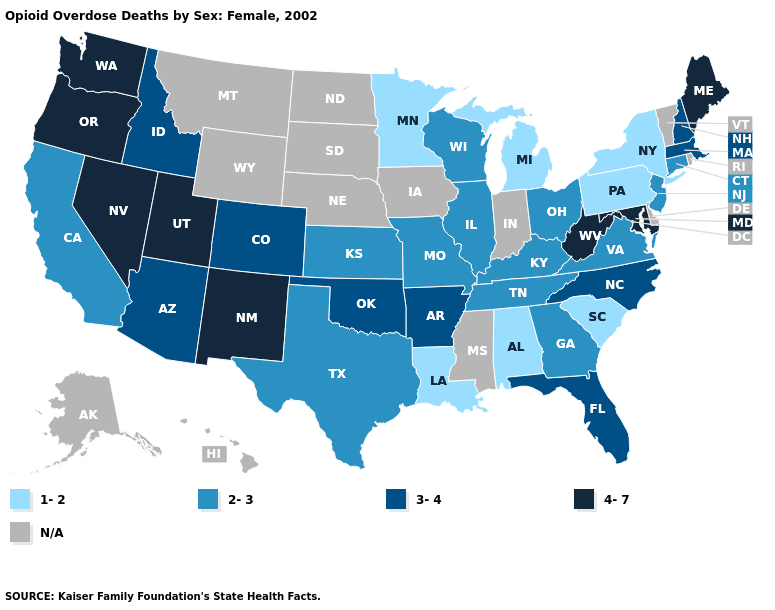What is the highest value in the USA?
Keep it brief. 4-7. How many symbols are there in the legend?
Short answer required. 5. Which states have the lowest value in the Northeast?
Short answer required. New York, Pennsylvania. Does Oregon have the highest value in the USA?
Keep it brief. Yes. What is the value of Tennessee?
Give a very brief answer. 2-3. Among the states that border North Carolina , does South Carolina have the lowest value?
Quick response, please. Yes. What is the value of Nevada?
Concise answer only. 4-7. Name the states that have a value in the range 2-3?
Short answer required. California, Connecticut, Georgia, Illinois, Kansas, Kentucky, Missouri, New Jersey, Ohio, Tennessee, Texas, Virginia, Wisconsin. What is the highest value in the Northeast ?
Be succinct. 4-7. How many symbols are there in the legend?
Keep it brief. 5. Which states have the lowest value in the West?
Write a very short answer. California. What is the value of Illinois?
Give a very brief answer. 2-3. Name the states that have a value in the range 2-3?
Answer briefly. California, Connecticut, Georgia, Illinois, Kansas, Kentucky, Missouri, New Jersey, Ohio, Tennessee, Texas, Virginia, Wisconsin. Among the states that border Wyoming , which have the lowest value?
Be succinct. Colorado, Idaho. 